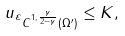<formula> <loc_0><loc_0><loc_500><loc_500>\| u _ { \varepsilon } \| _ { C ^ { 1 , \frac { \gamma } { 2 - \gamma } } ( \Omega ^ { \prime } ) } \leq K ,</formula> 